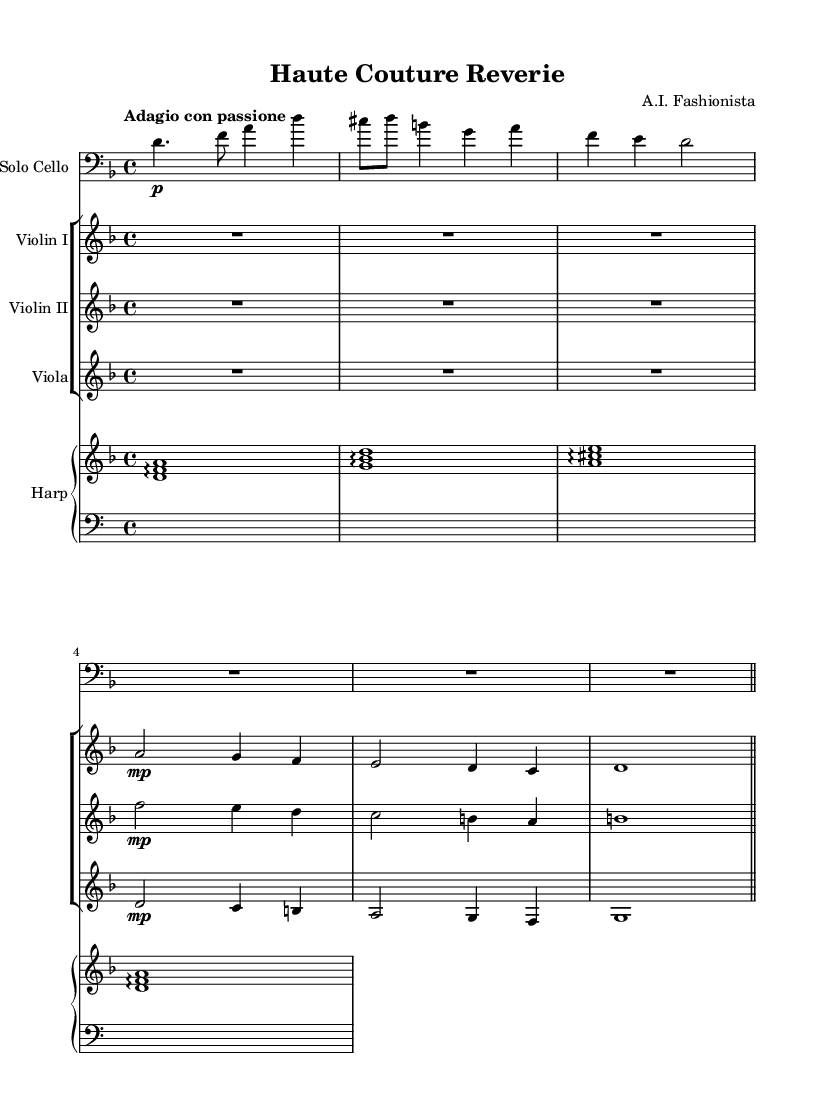What is the key signature of this music? The key signature is D minor, as indicated by the presence of one flat (B flat). This can be identified by reviewing the key signature at the beginning of the sheet music.
Answer: D minor What is the time signature of this music? The time signature is 4/4, as shown at the beginning of the score. It indicates that there are four beats in each measure and the quarter note receives one beat.
Answer: 4/4 What is the tempo marking given? The tempo marking is "Adagio con passione," which suggests a slow tempo with passion. This is explicitly stated in the global musical instructions.
Answer: Adagio con passione How many measures are there in the cello part? The cello part contains 6 measures, as can be counted by identifying the placement of vertical lines (bar lines) that separate each measure in the written music.
Answer: 6 Which instruments are involved in this piece? The instruments in this piece are Solo Cello, Violin I, Violin II, Viola, and Harp. This can be determined by looking at the staff labels in the score which denote the different instruments.
Answer: Solo Cello, Violin I, Violin II, Viola, Harp What dynamics are indicated in the music for the cello? The cello part has a dynamic indication of "p" (piano), meaning it should be played softly. This is specified in the music notation directly next to the notes.
Answer: Piano Which instrument plays arpeggios? The harp plays arpeggios, as indicated by the notation showing the chords being played in a broken manner in the harp part.
Answer: Harp 